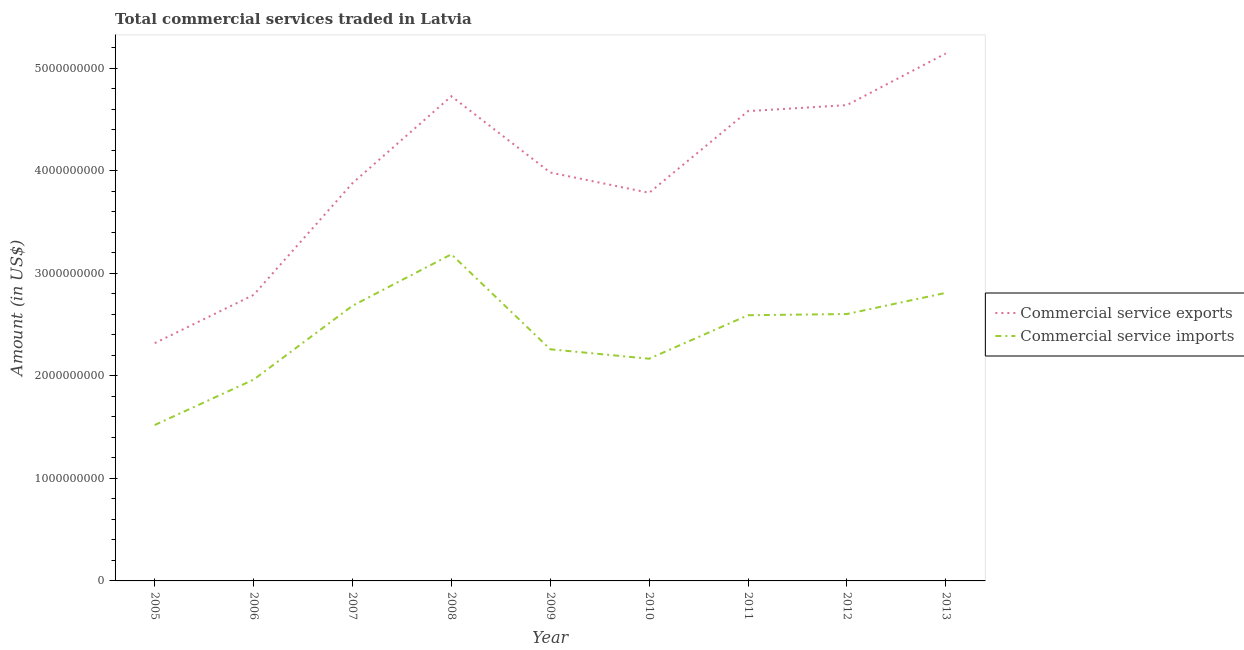Does the line corresponding to amount of commercial service exports intersect with the line corresponding to amount of commercial service imports?
Your response must be concise. No. What is the amount of commercial service exports in 2013?
Provide a succinct answer. 5.14e+09. Across all years, what is the maximum amount of commercial service exports?
Make the answer very short. 5.14e+09. Across all years, what is the minimum amount of commercial service exports?
Make the answer very short. 2.32e+09. In which year was the amount of commercial service imports maximum?
Ensure brevity in your answer.  2008. In which year was the amount of commercial service exports minimum?
Your answer should be very brief. 2005. What is the total amount of commercial service imports in the graph?
Keep it short and to the point. 2.18e+1. What is the difference between the amount of commercial service imports in 2006 and that in 2010?
Your answer should be compact. -2.04e+08. What is the difference between the amount of commercial service exports in 2007 and the amount of commercial service imports in 2006?
Keep it short and to the point. 1.92e+09. What is the average amount of commercial service exports per year?
Your answer should be compact. 3.98e+09. In the year 2009, what is the difference between the amount of commercial service exports and amount of commercial service imports?
Offer a terse response. 1.72e+09. In how many years, is the amount of commercial service exports greater than 600000000 US$?
Offer a very short reply. 9. What is the ratio of the amount of commercial service exports in 2007 to that in 2012?
Your answer should be very brief. 0.84. Is the amount of commercial service exports in 2010 less than that in 2012?
Give a very brief answer. Yes. What is the difference between the highest and the second highest amount of commercial service exports?
Make the answer very short. 4.17e+08. What is the difference between the highest and the lowest amount of commercial service exports?
Provide a succinct answer. 2.82e+09. In how many years, is the amount of commercial service exports greater than the average amount of commercial service exports taken over all years?
Offer a terse response. 4. Does the amount of commercial service exports monotonically increase over the years?
Make the answer very short. No. Is the amount of commercial service imports strictly greater than the amount of commercial service exports over the years?
Make the answer very short. No. Is the amount of commercial service imports strictly less than the amount of commercial service exports over the years?
Offer a terse response. Yes. How many years are there in the graph?
Make the answer very short. 9. How are the legend labels stacked?
Offer a very short reply. Vertical. What is the title of the graph?
Your answer should be compact. Total commercial services traded in Latvia. What is the label or title of the Y-axis?
Your answer should be compact. Amount (in US$). What is the Amount (in US$) in Commercial service exports in 2005?
Ensure brevity in your answer.  2.32e+09. What is the Amount (in US$) of Commercial service imports in 2005?
Your answer should be very brief. 1.52e+09. What is the Amount (in US$) in Commercial service exports in 2006?
Your response must be concise. 2.79e+09. What is the Amount (in US$) in Commercial service imports in 2006?
Give a very brief answer. 1.96e+09. What is the Amount (in US$) of Commercial service exports in 2007?
Give a very brief answer. 3.88e+09. What is the Amount (in US$) in Commercial service imports in 2007?
Make the answer very short. 2.68e+09. What is the Amount (in US$) in Commercial service exports in 2008?
Your response must be concise. 4.72e+09. What is the Amount (in US$) in Commercial service imports in 2008?
Make the answer very short. 3.18e+09. What is the Amount (in US$) in Commercial service exports in 2009?
Ensure brevity in your answer.  3.98e+09. What is the Amount (in US$) in Commercial service imports in 2009?
Ensure brevity in your answer.  2.26e+09. What is the Amount (in US$) in Commercial service exports in 2010?
Offer a very short reply. 3.78e+09. What is the Amount (in US$) of Commercial service imports in 2010?
Provide a short and direct response. 2.17e+09. What is the Amount (in US$) in Commercial service exports in 2011?
Give a very brief answer. 4.58e+09. What is the Amount (in US$) of Commercial service imports in 2011?
Provide a succinct answer. 2.59e+09. What is the Amount (in US$) in Commercial service exports in 2012?
Your answer should be very brief. 4.64e+09. What is the Amount (in US$) of Commercial service imports in 2012?
Your answer should be compact. 2.60e+09. What is the Amount (in US$) of Commercial service exports in 2013?
Give a very brief answer. 5.14e+09. What is the Amount (in US$) of Commercial service imports in 2013?
Offer a terse response. 2.81e+09. Across all years, what is the maximum Amount (in US$) in Commercial service exports?
Give a very brief answer. 5.14e+09. Across all years, what is the maximum Amount (in US$) of Commercial service imports?
Provide a succinct answer. 3.18e+09. Across all years, what is the minimum Amount (in US$) of Commercial service exports?
Offer a terse response. 2.32e+09. Across all years, what is the minimum Amount (in US$) of Commercial service imports?
Your answer should be very brief. 1.52e+09. What is the total Amount (in US$) of Commercial service exports in the graph?
Offer a terse response. 3.58e+1. What is the total Amount (in US$) in Commercial service imports in the graph?
Make the answer very short. 2.18e+1. What is the difference between the Amount (in US$) in Commercial service exports in 2005 and that in 2006?
Ensure brevity in your answer.  -4.70e+08. What is the difference between the Amount (in US$) in Commercial service imports in 2005 and that in 2006?
Make the answer very short. -4.42e+08. What is the difference between the Amount (in US$) of Commercial service exports in 2005 and that in 2007?
Make the answer very short. -1.56e+09. What is the difference between the Amount (in US$) in Commercial service imports in 2005 and that in 2007?
Your response must be concise. -1.16e+09. What is the difference between the Amount (in US$) in Commercial service exports in 2005 and that in 2008?
Offer a very short reply. -2.41e+09. What is the difference between the Amount (in US$) in Commercial service imports in 2005 and that in 2008?
Offer a very short reply. -1.66e+09. What is the difference between the Amount (in US$) in Commercial service exports in 2005 and that in 2009?
Provide a succinct answer. -1.66e+09. What is the difference between the Amount (in US$) in Commercial service imports in 2005 and that in 2009?
Provide a succinct answer. -7.38e+08. What is the difference between the Amount (in US$) of Commercial service exports in 2005 and that in 2010?
Your answer should be very brief. -1.47e+09. What is the difference between the Amount (in US$) of Commercial service imports in 2005 and that in 2010?
Your response must be concise. -6.46e+08. What is the difference between the Amount (in US$) in Commercial service exports in 2005 and that in 2011?
Offer a very short reply. -2.26e+09. What is the difference between the Amount (in US$) of Commercial service imports in 2005 and that in 2011?
Your response must be concise. -1.07e+09. What is the difference between the Amount (in US$) of Commercial service exports in 2005 and that in 2012?
Your answer should be very brief. -2.32e+09. What is the difference between the Amount (in US$) of Commercial service imports in 2005 and that in 2012?
Your response must be concise. -1.08e+09. What is the difference between the Amount (in US$) in Commercial service exports in 2005 and that in 2013?
Give a very brief answer. -2.82e+09. What is the difference between the Amount (in US$) of Commercial service imports in 2005 and that in 2013?
Give a very brief answer. -1.29e+09. What is the difference between the Amount (in US$) in Commercial service exports in 2006 and that in 2007?
Provide a succinct answer. -1.09e+09. What is the difference between the Amount (in US$) of Commercial service imports in 2006 and that in 2007?
Your answer should be very brief. -7.20e+08. What is the difference between the Amount (in US$) in Commercial service exports in 2006 and that in 2008?
Keep it short and to the point. -1.94e+09. What is the difference between the Amount (in US$) in Commercial service imports in 2006 and that in 2008?
Give a very brief answer. -1.22e+09. What is the difference between the Amount (in US$) of Commercial service exports in 2006 and that in 2009?
Give a very brief answer. -1.19e+09. What is the difference between the Amount (in US$) of Commercial service imports in 2006 and that in 2009?
Provide a short and direct response. -2.96e+08. What is the difference between the Amount (in US$) of Commercial service exports in 2006 and that in 2010?
Your response must be concise. -9.95e+08. What is the difference between the Amount (in US$) of Commercial service imports in 2006 and that in 2010?
Keep it short and to the point. -2.04e+08. What is the difference between the Amount (in US$) of Commercial service exports in 2006 and that in 2011?
Offer a terse response. -1.79e+09. What is the difference between the Amount (in US$) in Commercial service imports in 2006 and that in 2011?
Make the answer very short. -6.28e+08. What is the difference between the Amount (in US$) in Commercial service exports in 2006 and that in 2012?
Your response must be concise. -1.85e+09. What is the difference between the Amount (in US$) of Commercial service imports in 2006 and that in 2012?
Make the answer very short. -6.40e+08. What is the difference between the Amount (in US$) in Commercial service exports in 2006 and that in 2013?
Your answer should be compact. -2.35e+09. What is the difference between the Amount (in US$) of Commercial service imports in 2006 and that in 2013?
Offer a very short reply. -8.46e+08. What is the difference between the Amount (in US$) in Commercial service exports in 2007 and that in 2008?
Give a very brief answer. -8.47e+08. What is the difference between the Amount (in US$) in Commercial service imports in 2007 and that in 2008?
Offer a terse response. -5.02e+08. What is the difference between the Amount (in US$) of Commercial service exports in 2007 and that in 2009?
Your answer should be compact. -1.04e+08. What is the difference between the Amount (in US$) in Commercial service imports in 2007 and that in 2009?
Keep it short and to the point. 4.24e+08. What is the difference between the Amount (in US$) of Commercial service exports in 2007 and that in 2010?
Keep it short and to the point. 9.43e+07. What is the difference between the Amount (in US$) of Commercial service imports in 2007 and that in 2010?
Offer a very short reply. 5.16e+08. What is the difference between the Amount (in US$) in Commercial service exports in 2007 and that in 2011?
Make the answer very short. -7.02e+08. What is the difference between the Amount (in US$) of Commercial service imports in 2007 and that in 2011?
Offer a very short reply. 9.23e+07. What is the difference between the Amount (in US$) of Commercial service exports in 2007 and that in 2012?
Ensure brevity in your answer.  -7.61e+08. What is the difference between the Amount (in US$) of Commercial service imports in 2007 and that in 2012?
Ensure brevity in your answer.  8.04e+07. What is the difference between the Amount (in US$) of Commercial service exports in 2007 and that in 2013?
Your response must be concise. -1.26e+09. What is the difference between the Amount (in US$) of Commercial service imports in 2007 and that in 2013?
Provide a succinct answer. -1.26e+08. What is the difference between the Amount (in US$) of Commercial service exports in 2008 and that in 2009?
Your answer should be very brief. 7.44e+08. What is the difference between the Amount (in US$) in Commercial service imports in 2008 and that in 2009?
Make the answer very short. 9.26e+08. What is the difference between the Amount (in US$) of Commercial service exports in 2008 and that in 2010?
Ensure brevity in your answer.  9.41e+08. What is the difference between the Amount (in US$) in Commercial service imports in 2008 and that in 2010?
Make the answer very short. 1.02e+09. What is the difference between the Amount (in US$) of Commercial service exports in 2008 and that in 2011?
Provide a succinct answer. 1.45e+08. What is the difference between the Amount (in US$) of Commercial service imports in 2008 and that in 2011?
Keep it short and to the point. 5.94e+08. What is the difference between the Amount (in US$) of Commercial service exports in 2008 and that in 2012?
Give a very brief answer. 8.65e+07. What is the difference between the Amount (in US$) of Commercial service imports in 2008 and that in 2012?
Your response must be concise. 5.82e+08. What is the difference between the Amount (in US$) of Commercial service exports in 2008 and that in 2013?
Your answer should be compact. -4.17e+08. What is the difference between the Amount (in US$) of Commercial service imports in 2008 and that in 2013?
Your answer should be very brief. 3.76e+08. What is the difference between the Amount (in US$) of Commercial service exports in 2009 and that in 2010?
Offer a very short reply. 1.98e+08. What is the difference between the Amount (in US$) of Commercial service imports in 2009 and that in 2010?
Your answer should be very brief. 9.19e+07. What is the difference between the Amount (in US$) in Commercial service exports in 2009 and that in 2011?
Provide a succinct answer. -5.98e+08. What is the difference between the Amount (in US$) in Commercial service imports in 2009 and that in 2011?
Ensure brevity in your answer.  -3.32e+08. What is the difference between the Amount (in US$) of Commercial service exports in 2009 and that in 2012?
Keep it short and to the point. -6.57e+08. What is the difference between the Amount (in US$) of Commercial service imports in 2009 and that in 2012?
Make the answer very short. -3.44e+08. What is the difference between the Amount (in US$) in Commercial service exports in 2009 and that in 2013?
Provide a short and direct response. -1.16e+09. What is the difference between the Amount (in US$) in Commercial service imports in 2009 and that in 2013?
Your answer should be very brief. -5.50e+08. What is the difference between the Amount (in US$) of Commercial service exports in 2010 and that in 2011?
Provide a succinct answer. -7.96e+08. What is the difference between the Amount (in US$) in Commercial service imports in 2010 and that in 2011?
Provide a short and direct response. -4.24e+08. What is the difference between the Amount (in US$) of Commercial service exports in 2010 and that in 2012?
Provide a short and direct response. -8.55e+08. What is the difference between the Amount (in US$) of Commercial service imports in 2010 and that in 2012?
Give a very brief answer. -4.36e+08. What is the difference between the Amount (in US$) in Commercial service exports in 2010 and that in 2013?
Offer a terse response. -1.36e+09. What is the difference between the Amount (in US$) of Commercial service imports in 2010 and that in 2013?
Your answer should be very brief. -6.42e+08. What is the difference between the Amount (in US$) in Commercial service exports in 2011 and that in 2012?
Keep it short and to the point. -5.86e+07. What is the difference between the Amount (in US$) in Commercial service imports in 2011 and that in 2012?
Provide a short and direct response. -1.19e+07. What is the difference between the Amount (in US$) of Commercial service exports in 2011 and that in 2013?
Make the answer very short. -5.62e+08. What is the difference between the Amount (in US$) of Commercial service imports in 2011 and that in 2013?
Your answer should be compact. -2.18e+08. What is the difference between the Amount (in US$) in Commercial service exports in 2012 and that in 2013?
Your answer should be compact. -5.04e+08. What is the difference between the Amount (in US$) of Commercial service imports in 2012 and that in 2013?
Keep it short and to the point. -2.06e+08. What is the difference between the Amount (in US$) in Commercial service exports in 2005 and the Amount (in US$) in Commercial service imports in 2006?
Your answer should be very brief. 3.56e+08. What is the difference between the Amount (in US$) of Commercial service exports in 2005 and the Amount (in US$) of Commercial service imports in 2007?
Offer a terse response. -3.64e+08. What is the difference between the Amount (in US$) in Commercial service exports in 2005 and the Amount (in US$) in Commercial service imports in 2008?
Your answer should be very brief. -8.66e+08. What is the difference between the Amount (in US$) in Commercial service exports in 2005 and the Amount (in US$) in Commercial service imports in 2009?
Your answer should be compact. 6.01e+07. What is the difference between the Amount (in US$) of Commercial service exports in 2005 and the Amount (in US$) of Commercial service imports in 2010?
Keep it short and to the point. 1.52e+08. What is the difference between the Amount (in US$) in Commercial service exports in 2005 and the Amount (in US$) in Commercial service imports in 2011?
Keep it short and to the point. -2.72e+08. What is the difference between the Amount (in US$) of Commercial service exports in 2005 and the Amount (in US$) of Commercial service imports in 2012?
Your answer should be very brief. -2.84e+08. What is the difference between the Amount (in US$) in Commercial service exports in 2005 and the Amount (in US$) in Commercial service imports in 2013?
Offer a very short reply. -4.90e+08. What is the difference between the Amount (in US$) of Commercial service exports in 2006 and the Amount (in US$) of Commercial service imports in 2007?
Make the answer very short. 1.06e+08. What is the difference between the Amount (in US$) in Commercial service exports in 2006 and the Amount (in US$) in Commercial service imports in 2008?
Your response must be concise. -3.96e+08. What is the difference between the Amount (in US$) in Commercial service exports in 2006 and the Amount (in US$) in Commercial service imports in 2009?
Give a very brief answer. 5.30e+08. What is the difference between the Amount (in US$) of Commercial service exports in 2006 and the Amount (in US$) of Commercial service imports in 2010?
Make the answer very short. 6.22e+08. What is the difference between the Amount (in US$) in Commercial service exports in 2006 and the Amount (in US$) in Commercial service imports in 2011?
Offer a terse response. 1.98e+08. What is the difference between the Amount (in US$) in Commercial service exports in 2006 and the Amount (in US$) in Commercial service imports in 2012?
Your response must be concise. 1.86e+08. What is the difference between the Amount (in US$) of Commercial service exports in 2006 and the Amount (in US$) of Commercial service imports in 2013?
Keep it short and to the point. -1.97e+07. What is the difference between the Amount (in US$) in Commercial service exports in 2007 and the Amount (in US$) in Commercial service imports in 2008?
Keep it short and to the point. 6.94e+08. What is the difference between the Amount (in US$) in Commercial service exports in 2007 and the Amount (in US$) in Commercial service imports in 2009?
Keep it short and to the point. 1.62e+09. What is the difference between the Amount (in US$) of Commercial service exports in 2007 and the Amount (in US$) of Commercial service imports in 2010?
Your response must be concise. 1.71e+09. What is the difference between the Amount (in US$) of Commercial service exports in 2007 and the Amount (in US$) of Commercial service imports in 2011?
Your response must be concise. 1.29e+09. What is the difference between the Amount (in US$) in Commercial service exports in 2007 and the Amount (in US$) in Commercial service imports in 2012?
Make the answer very short. 1.28e+09. What is the difference between the Amount (in US$) in Commercial service exports in 2007 and the Amount (in US$) in Commercial service imports in 2013?
Your answer should be very brief. 1.07e+09. What is the difference between the Amount (in US$) of Commercial service exports in 2008 and the Amount (in US$) of Commercial service imports in 2009?
Provide a succinct answer. 2.47e+09. What is the difference between the Amount (in US$) of Commercial service exports in 2008 and the Amount (in US$) of Commercial service imports in 2010?
Keep it short and to the point. 2.56e+09. What is the difference between the Amount (in US$) in Commercial service exports in 2008 and the Amount (in US$) in Commercial service imports in 2011?
Your answer should be compact. 2.13e+09. What is the difference between the Amount (in US$) in Commercial service exports in 2008 and the Amount (in US$) in Commercial service imports in 2012?
Offer a terse response. 2.12e+09. What is the difference between the Amount (in US$) of Commercial service exports in 2008 and the Amount (in US$) of Commercial service imports in 2013?
Give a very brief answer. 1.92e+09. What is the difference between the Amount (in US$) of Commercial service exports in 2009 and the Amount (in US$) of Commercial service imports in 2010?
Provide a short and direct response. 1.82e+09. What is the difference between the Amount (in US$) of Commercial service exports in 2009 and the Amount (in US$) of Commercial service imports in 2011?
Ensure brevity in your answer.  1.39e+09. What is the difference between the Amount (in US$) of Commercial service exports in 2009 and the Amount (in US$) of Commercial service imports in 2012?
Your answer should be very brief. 1.38e+09. What is the difference between the Amount (in US$) in Commercial service exports in 2009 and the Amount (in US$) in Commercial service imports in 2013?
Keep it short and to the point. 1.17e+09. What is the difference between the Amount (in US$) of Commercial service exports in 2010 and the Amount (in US$) of Commercial service imports in 2011?
Keep it short and to the point. 1.19e+09. What is the difference between the Amount (in US$) of Commercial service exports in 2010 and the Amount (in US$) of Commercial service imports in 2012?
Offer a terse response. 1.18e+09. What is the difference between the Amount (in US$) in Commercial service exports in 2010 and the Amount (in US$) in Commercial service imports in 2013?
Your answer should be very brief. 9.75e+08. What is the difference between the Amount (in US$) of Commercial service exports in 2011 and the Amount (in US$) of Commercial service imports in 2012?
Provide a succinct answer. 1.98e+09. What is the difference between the Amount (in US$) in Commercial service exports in 2011 and the Amount (in US$) in Commercial service imports in 2013?
Keep it short and to the point. 1.77e+09. What is the difference between the Amount (in US$) of Commercial service exports in 2012 and the Amount (in US$) of Commercial service imports in 2013?
Your response must be concise. 1.83e+09. What is the average Amount (in US$) of Commercial service exports per year?
Give a very brief answer. 3.98e+09. What is the average Amount (in US$) of Commercial service imports per year?
Make the answer very short. 2.42e+09. In the year 2005, what is the difference between the Amount (in US$) of Commercial service exports and Amount (in US$) of Commercial service imports?
Make the answer very short. 7.98e+08. In the year 2006, what is the difference between the Amount (in US$) in Commercial service exports and Amount (in US$) in Commercial service imports?
Ensure brevity in your answer.  8.26e+08. In the year 2007, what is the difference between the Amount (in US$) of Commercial service exports and Amount (in US$) of Commercial service imports?
Offer a very short reply. 1.20e+09. In the year 2008, what is the difference between the Amount (in US$) of Commercial service exports and Amount (in US$) of Commercial service imports?
Provide a succinct answer. 1.54e+09. In the year 2009, what is the difference between the Amount (in US$) in Commercial service exports and Amount (in US$) in Commercial service imports?
Your answer should be very brief. 1.72e+09. In the year 2010, what is the difference between the Amount (in US$) of Commercial service exports and Amount (in US$) of Commercial service imports?
Provide a succinct answer. 1.62e+09. In the year 2011, what is the difference between the Amount (in US$) of Commercial service exports and Amount (in US$) of Commercial service imports?
Give a very brief answer. 1.99e+09. In the year 2012, what is the difference between the Amount (in US$) in Commercial service exports and Amount (in US$) in Commercial service imports?
Provide a succinct answer. 2.04e+09. In the year 2013, what is the difference between the Amount (in US$) of Commercial service exports and Amount (in US$) of Commercial service imports?
Keep it short and to the point. 2.33e+09. What is the ratio of the Amount (in US$) of Commercial service exports in 2005 to that in 2006?
Make the answer very short. 0.83. What is the ratio of the Amount (in US$) in Commercial service imports in 2005 to that in 2006?
Provide a short and direct response. 0.77. What is the ratio of the Amount (in US$) of Commercial service exports in 2005 to that in 2007?
Provide a succinct answer. 0.6. What is the ratio of the Amount (in US$) in Commercial service imports in 2005 to that in 2007?
Provide a succinct answer. 0.57. What is the ratio of the Amount (in US$) of Commercial service exports in 2005 to that in 2008?
Your response must be concise. 0.49. What is the ratio of the Amount (in US$) in Commercial service imports in 2005 to that in 2008?
Keep it short and to the point. 0.48. What is the ratio of the Amount (in US$) in Commercial service exports in 2005 to that in 2009?
Offer a very short reply. 0.58. What is the ratio of the Amount (in US$) of Commercial service imports in 2005 to that in 2009?
Offer a very short reply. 0.67. What is the ratio of the Amount (in US$) of Commercial service exports in 2005 to that in 2010?
Offer a terse response. 0.61. What is the ratio of the Amount (in US$) in Commercial service imports in 2005 to that in 2010?
Provide a short and direct response. 0.7. What is the ratio of the Amount (in US$) in Commercial service exports in 2005 to that in 2011?
Your answer should be compact. 0.51. What is the ratio of the Amount (in US$) of Commercial service imports in 2005 to that in 2011?
Your response must be concise. 0.59. What is the ratio of the Amount (in US$) in Commercial service exports in 2005 to that in 2012?
Keep it short and to the point. 0.5. What is the ratio of the Amount (in US$) in Commercial service imports in 2005 to that in 2012?
Your answer should be very brief. 0.58. What is the ratio of the Amount (in US$) of Commercial service exports in 2005 to that in 2013?
Your response must be concise. 0.45. What is the ratio of the Amount (in US$) in Commercial service imports in 2005 to that in 2013?
Your answer should be compact. 0.54. What is the ratio of the Amount (in US$) of Commercial service exports in 2006 to that in 2007?
Provide a succinct answer. 0.72. What is the ratio of the Amount (in US$) of Commercial service imports in 2006 to that in 2007?
Your answer should be very brief. 0.73. What is the ratio of the Amount (in US$) in Commercial service exports in 2006 to that in 2008?
Your answer should be compact. 0.59. What is the ratio of the Amount (in US$) in Commercial service imports in 2006 to that in 2008?
Your answer should be very brief. 0.62. What is the ratio of the Amount (in US$) in Commercial service exports in 2006 to that in 2009?
Give a very brief answer. 0.7. What is the ratio of the Amount (in US$) of Commercial service imports in 2006 to that in 2009?
Give a very brief answer. 0.87. What is the ratio of the Amount (in US$) of Commercial service exports in 2006 to that in 2010?
Provide a succinct answer. 0.74. What is the ratio of the Amount (in US$) of Commercial service imports in 2006 to that in 2010?
Make the answer very short. 0.91. What is the ratio of the Amount (in US$) of Commercial service exports in 2006 to that in 2011?
Offer a terse response. 0.61. What is the ratio of the Amount (in US$) in Commercial service imports in 2006 to that in 2011?
Ensure brevity in your answer.  0.76. What is the ratio of the Amount (in US$) of Commercial service exports in 2006 to that in 2012?
Make the answer very short. 0.6. What is the ratio of the Amount (in US$) of Commercial service imports in 2006 to that in 2012?
Keep it short and to the point. 0.75. What is the ratio of the Amount (in US$) of Commercial service exports in 2006 to that in 2013?
Your response must be concise. 0.54. What is the ratio of the Amount (in US$) in Commercial service imports in 2006 to that in 2013?
Make the answer very short. 0.7. What is the ratio of the Amount (in US$) in Commercial service exports in 2007 to that in 2008?
Provide a short and direct response. 0.82. What is the ratio of the Amount (in US$) of Commercial service imports in 2007 to that in 2008?
Keep it short and to the point. 0.84. What is the ratio of the Amount (in US$) of Commercial service exports in 2007 to that in 2009?
Make the answer very short. 0.97. What is the ratio of the Amount (in US$) of Commercial service imports in 2007 to that in 2009?
Provide a short and direct response. 1.19. What is the ratio of the Amount (in US$) in Commercial service exports in 2007 to that in 2010?
Keep it short and to the point. 1.02. What is the ratio of the Amount (in US$) of Commercial service imports in 2007 to that in 2010?
Offer a very short reply. 1.24. What is the ratio of the Amount (in US$) of Commercial service exports in 2007 to that in 2011?
Your answer should be very brief. 0.85. What is the ratio of the Amount (in US$) in Commercial service imports in 2007 to that in 2011?
Provide a short and direct response. 1.04. What is the ratio of the Amount (in US$) of Commercial service exports in 2007 to that in 2012?
Ensure brevity in your answer.  0.84. What is the ratio of the Amount (in US$) of Commercial service imports in 2007 to that in 2012?
Make the answer very short. 1.03. What is the ratio of the Amount (in US$) of Commercial service exports in 2007 to that in 2013?
Your response must be concise. 0.75. What is the ratio of the Amount (in US$) of Commercial service imports in 2007 to that in 2013?
Keep it short and to the point. 0.96. What is the ratio of the Amount (in US$) in Commercial service exports in 2008 to that in 2009?
Your response must be concise. 1.19. What is the ratio of the Amount (in US$) of Commercial service imports in 2008 to that in 2009?
Your answer should be compact. 1.41. What is the ratio of the Amount (in US$) of Commercial service exports in 2008 to that in 2010?
Your answer should be very brief. 1.25. What is the ratio of the Amount (in US$) of Commercial service imports in 2008 to that in 2010?
Ensure brevity in your answer.  1.47. What is the ratio of the Amount (in US$) of Commercial service exports in 2008 to that in 2011?
Provide a short and direct response. 1.03. What is the ratio of the Amount (in US$) in Commercial service imports in 2008 to that in 2011?
Your response must be concise. 1.23. What is the ratio of the Amount (in US$) of Commercial service exports in 2008 to that in 2012?
Your answer should be compact. 1.02. What is the ratio of the Amount (in US$) in Commercial service imports in 2008 to that in 2012?
Make the answer very short. 1.22. What is the ratio of the Amount (in US$) in Commercial service exports in 2008 to that in 2013?
Your response must be concise. 0.92. What is the ratio of the Amount (in US$) in Commercial service imports in 2008 to that in 2013?
Make the answer very short. 1.13. What is the ratio of the Amount (in US$) in Commercial service exports in 2009 to that in 2010?
Keep it short and to the point. 1.05. What is the ratio of the Amount (in US$) in Commercial service imports in 2009 to that in 2010?
Ensure brevity in your answer.  1.04. What is the ratio of the Amount (in US$) in Commercial service exports in 2009 to that in 2011?
Ensure brevity in your answer.  0.87. What is the ratio of the Amount (in US$) in Commercial service imports in 2009 to that in 2011?
Your answer should be very brief. 0.87. What is the ratio of the Amount (in US$) in Commercial service exports in 2009 to that in 2012?
Give a very brief answer. 0.86. What is the ratio of the Amount (in US$) in Commercial service imports in 2009 to that in 2012?
Your response must be concise. 0.87. What is the ratio of the Amount (in US$) in Commercial service exports in 2009 to that in 2013?
Provide a succinct answer. 0.77. What is the ratio of the Amount (in US$) in Commercial service imports in 2009 to that in 2013?
Your answer should be very brief. 0.8. What is the ratio of the Amount (in US$) in Commercial service exports in 2010 to that in 2011?
Provide a succinct answer. 0.83. What is the ratio of the Amount (in US$) of Commercial service imports in 2010 to that in 2011?
Your response must be concise. 0.84. What is the ratio of the Amount (in US$) of Commercial service exports in 2010 to that in 2012?
Your answer should be compact. 0.82. What is the ratio of the Amount (in US$) in Commercial service imports in 2010 to that in 2012?
Make the answer very short. 0.83. What is the ratio of the Amount (in US$) in Commercial service exports in 2010 to that in 2013?
Keep it short and to the point. 0.74. What is the ratio of the Amount (in US$) of Commercial service imports in 2010 to that in 2013?
Offer a terse response. 0.77. What is the ratio of the Amount (in US$) of Commercial service exports in 2011 to that in 2012?
Your response must be concise. 0.99. What is the ratio of the Amount (in US$) of Commercial service exports in 2011 to that in 2013?
Provide a succinct answer. 0.89. What is the ratio of the Amount (in US$) in Commercial service imports in 2011 to that in 2013?
Provide a short and direct response. 0.92. What is the ratio of the Amount (in US$) in Commercial service exports in 2012 to that in 2013?
Make the answer very short. 0.9. What is the ratio of the Amount (in US$) of Commercial service imports in 2012 to that in 2013?
Give a very brief answer. 0.93. What is the difference between the highest and the second highest Amount (in US$) of Commercial service exports?
Ensure brevity in your answer.  4.17e+08. What is the difference between the highest and the second highest Amount (in US$) in Commercial service imports?
Ensure brevity in your answer.  3.76e+08. What is the difference between the highest and the lowest Amount (in US$) in Commercial service exports?
Ensure brevity in your answer.  2.82e+09. What is the difference between the highest and the lowest Amount (in US$) of Commercial service imports?
Offer a very short reply. 1.66e+09. 